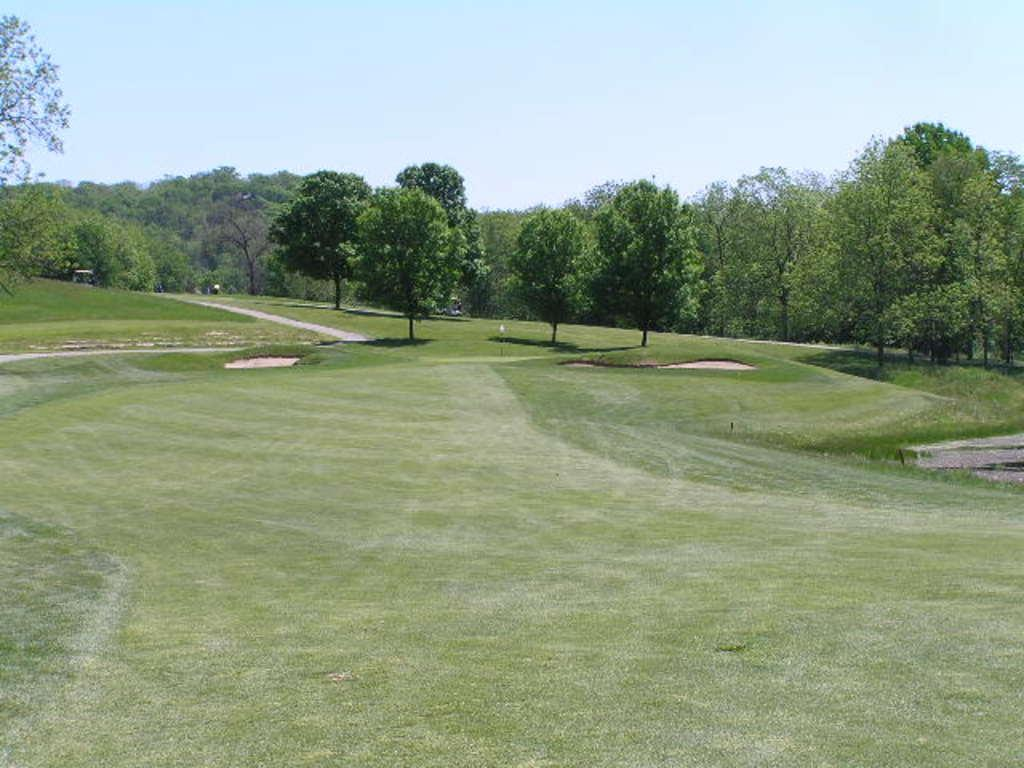What type of location is depicted in the image? There is a golf ground in the image. What can be seen in the background of the image? There are many trees in the image. What type of show can be seen on the golf ground in the image? There is no show present on the golf ground in the image; it is a golf course with trees in the background. 